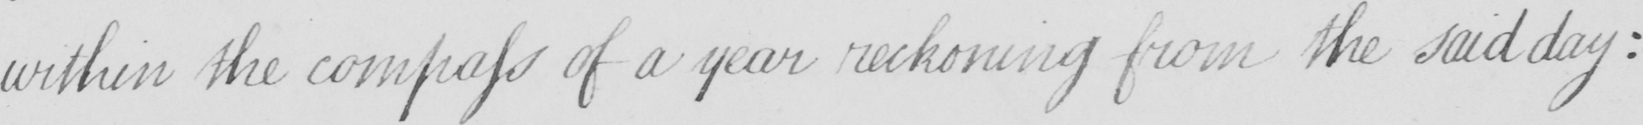What is written in this line of handwriting? within the compass of a year reckoning from the said day : 